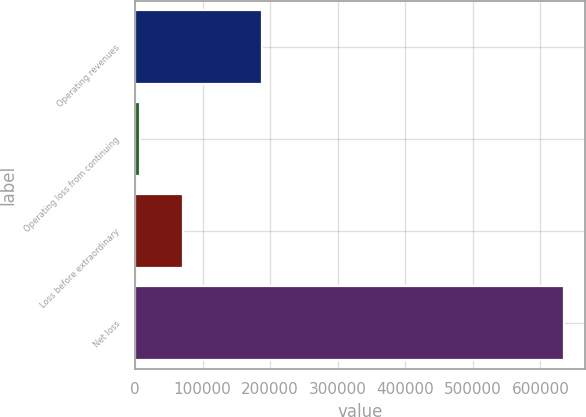<chart> <loc_0><loc_0><loc_500><loc_500><bar_chart><fcel>Operating revenues<fcel>Operating loss from continuing<fcel>Loss before extraordinary<fcel>Net loss<nl><fcel>187751<fcel>7844<fcel>70706<fcel>634389<nl></chart> 